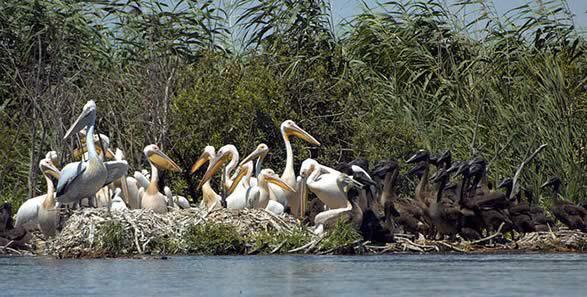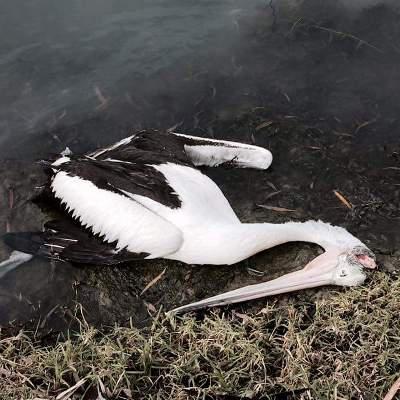The first image is the image on the left, the second image is the image on the right. Evaluate the accuracy of this statement regarding the images: "There is only one bird in one of the images.". Is it true? Answer yes or no. Yes. The first image is the image on the left, the second image is the image on the right. Evaluate the accuracy of this statement regarding the images: "there is one bird in the right side photo". Is it true? Answer yes or no. Yes. 